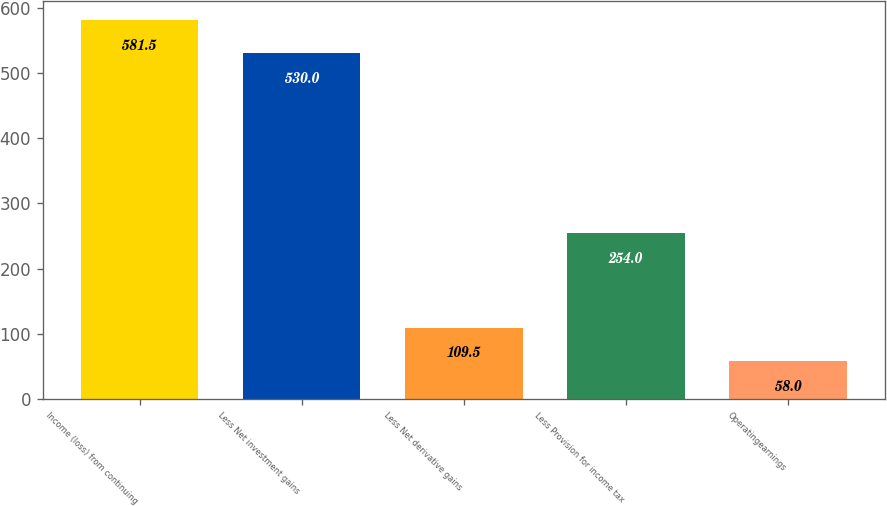Convert chart. <chart><loc_0><loc_0><loc_500><loc_500><bar_chart><fcel>Income (loss) from continuing<fcel>Less Net investment gains<fcel>Less Net derivative gains<fcel>Less Provision for income tax<fcel>Operatingearnings<nl><fcel>581.5<fcel>530<fcel>109.5<fcel>254<fcel>58<nl></chart> 